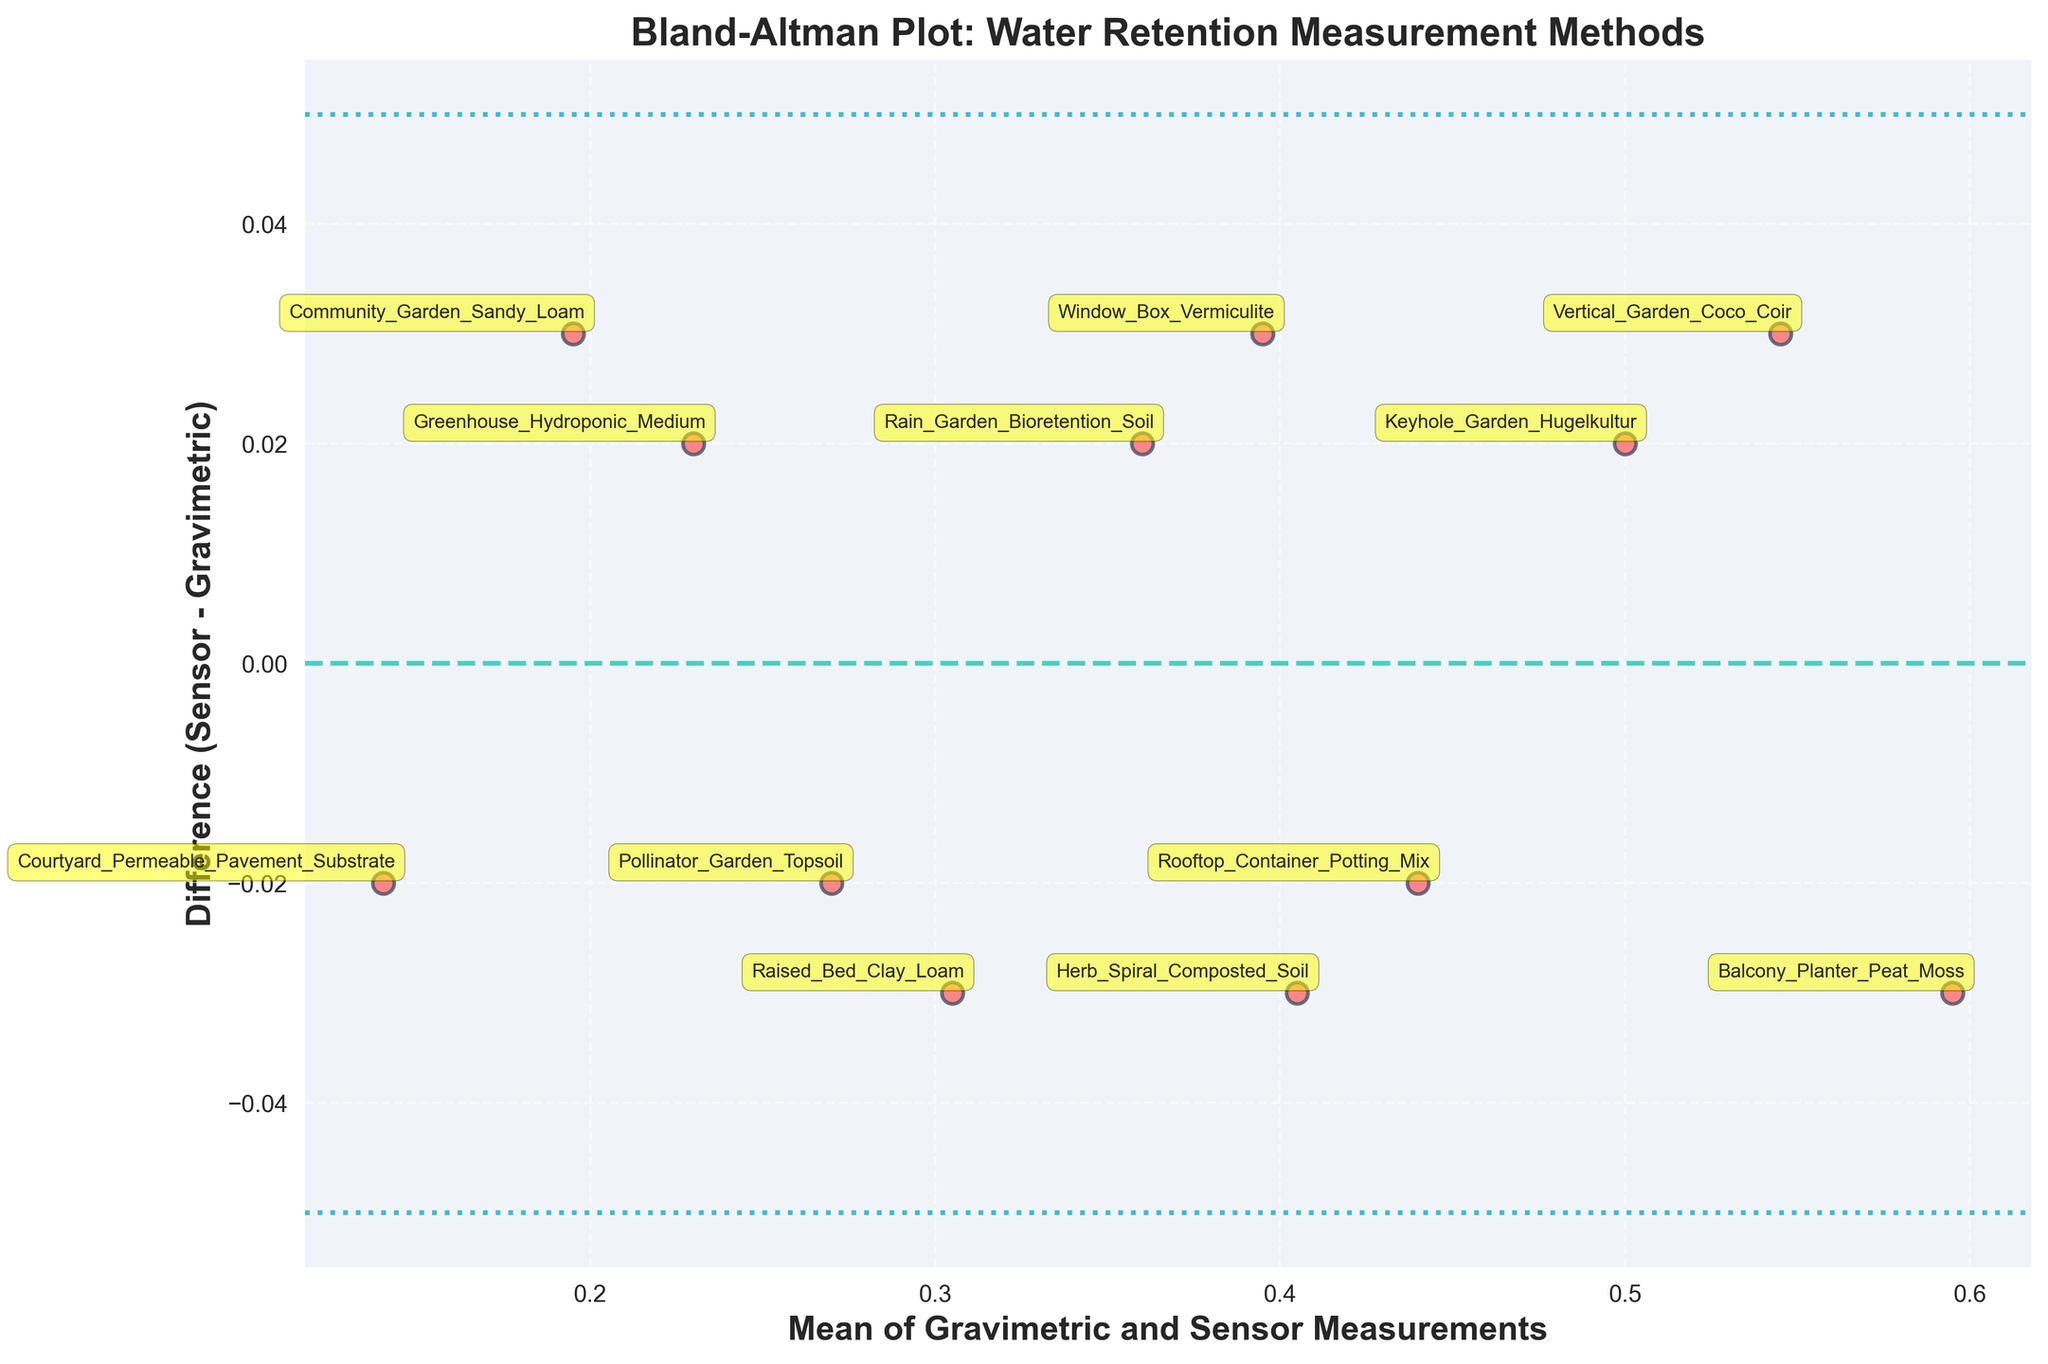What is the title of the plot? The title of the plot is located at the top of the figure. It describes the main topic of the plot, related to comparing water retention measurement methods.
Answer: Bland-Altman Plot: Water Retention Measurement Methods How many data points are there on the plot? Count the number of individual points (data points) shown in the scatter plot. Each point represents a soil type used in the urban garden water retention study.
Answer: 12 What is the mean difference between the sensor and gravimetric measurements? The mean difference is indicated by a horizontal dashed line labeled 'Mean' in the plot. The y-coordinate of this line represents the mean difference.
Answer: 0.01 What do the dotted lines on the plot represent? The dotted lines are parallel to the mean difference line and indicate the limits of agreement. These are set at the mean difference plus and minus 1.96 times the standard deviation.
Answer: Limits of agreement Which method has the highest positive difference between the moisture sensor and gravimetric measurements? Find the data point with the largest positive difference on the y-axis. The label next to this point tells which method it represents.
Answer: Vertical Garden Coco Coir How is the bias in measurements represented in this plot? Bias in the measurements is represented by the mean difference line. It shows if there is a consistent overestimation or underestimation by the sensor compared to the gravimetric method.
Answer: Mean difference line What is the range of the limits of agreement? The range is the distance between the upper and lower dotted lines. These lines indicate the limits of agreement, calculated as the mean difference ± 1.96 times the standard deviation.
Answer: From -0.036 to 0.056 Which soil types are shown to overestimate water retention compared to the gravimetric method? Look for data points above the mean difference line. The labels next to these points identify the soil types where the moisture sensor overestimates water retention.
Answer: Community Garden Sandy Loam, Vertical Garden Coco Coir, Rain Garden Bioretention Soil, Greenhouse Hydroponic Medium Which soil types have sensor readings that are closer to the gravimetric measurements? Data points near the zero difference line (mean difference line) indicate smaller discrepancies between the sensor and gravimetric measurements. These labels identify the soil types.
Answer: Rooftop Container Potting Mix, Raised Bed Clay Loam, Pollinator Garden Topsoil 